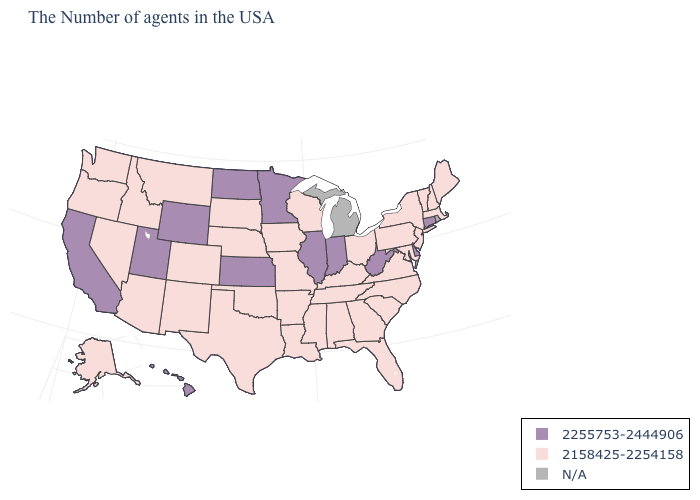What is the lowest value in the West?
Answer briefly. 2158425-2254158. How many symbols are there in the legend?
Be succinct. 3. What is the value of Delaware?
Short answer required. 2255753-2444906. What is the highest value in states that border Georgia?
Short answer required. 2158425-2254158. What is the highest value in the South ?
Short answer required. 2255753-2444906. What is the value of Nebraska?
Answer briefly. 2158425-2254158. What is the value of Massachusetts?
Answer briefly. 2158425-2254158. Name the states that have a value in the range N/A?
Short answer required. Rhode Island, Michigan. What is the highest value in states that border West Virginia?
Answer briefly. 2158425-2254158. Name the states that have a value in the range 2158425-2254158?
Give a very brief answer. Maine, Massachusetts, New Hampshire, Vermont, New York, New Jersey, Maryland, Pennsylvania, Virginia, North Carolina, South Carolina, Ohio, Florida, Georgia, Kentucky, Alabama, Tennessee, Wisconsin, Mississippi, Louisiana, Missouri, Arkansas, Iowa, Nebraska, Oklahoma, Texas, South Dakota, Colorado, New Mexico, Montana, Arizona, Idaho, Nevada, Washington, Oregon, Alaska. What is the value of Iowa?
Quick response, please. 2158425-2254158. What is the highest value in the USA?
Quick response, please. 2255753-2444906. Which states have the highest value in the USA?
Write a very short answer. Connecticut, Delaware, West Virginia, Indiana, Illinois, Minnesota, Kansas, North Dakota, Wyoming, Utah, California, Hawaii. Does New Mexico have the lowest value in the USA?
Keep it brief. Yes. 